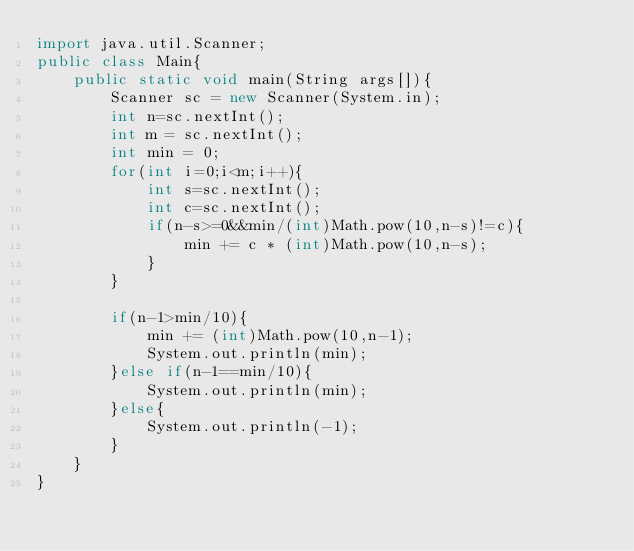Convert code to text. <code><loc_0><loc_0><loc_500><loc_500><_Java_>import java.util.Scanner;
public class Main{
	public static void main(String args[]){
		Scanner sc = new Scanner(System.in);
		int n=sc.nextInt();
		int m = sc.nextInt();
		int min = 0;
		for(int i=0;i<m;i++){
			int s=sc.nextInt();
			int c=sc.nextInt();
			if(n-s>=0&&min/(int)Math.pow(10,n-s)!=c){
				min += c * (int)Math.pow(10,n-s);
			}
		}

		if(n-1>min/10){
			min += (int)Math.pow(10,n-1);
			System.out.println(min);
		}else if(n-1==min/10){
			System.out.println(min);
		}else{
			System.out.println(-1);
		}
	}
}
</code> 